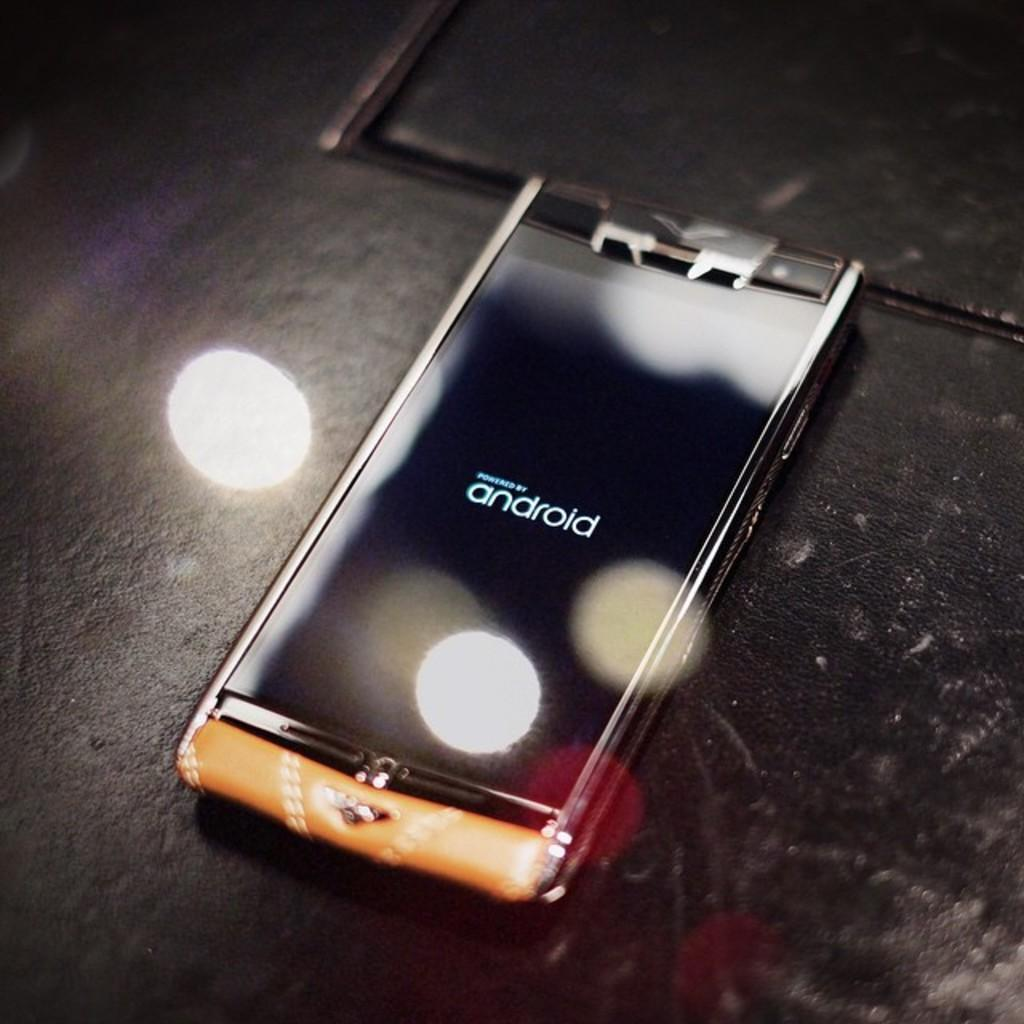<image>
Describe the image concisely. A phone that is powered by android is on a black surface. 